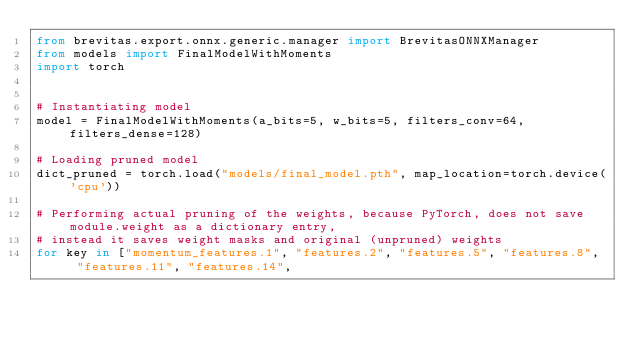Convert code to text. <code><loc_0><loc_0><loc_500><loc_500><_Python_>from brevitas.export.onnx.generic.manager import BrevitasONNXManager
from models import FinalModelWithMoments
import torch


# Instantiating model
model = FinalModelWithMoments(a_bits=5, w_bits=5, filters_conv=64, filters_dense=128)

# Loading pruned model
dict_pruned = torch.load("models/final_model.pth", map_location=torch.device('cpu'))

# Performing actual pruning of the weights, because PyTorch, does not save module.weight as a dictionary entry,
# instead it saves weight masks and original (unpruned) weights
for key in ["momentum_features.1", "features.2", "features.5", "features.8",  "features.11", "features.14",</code> 